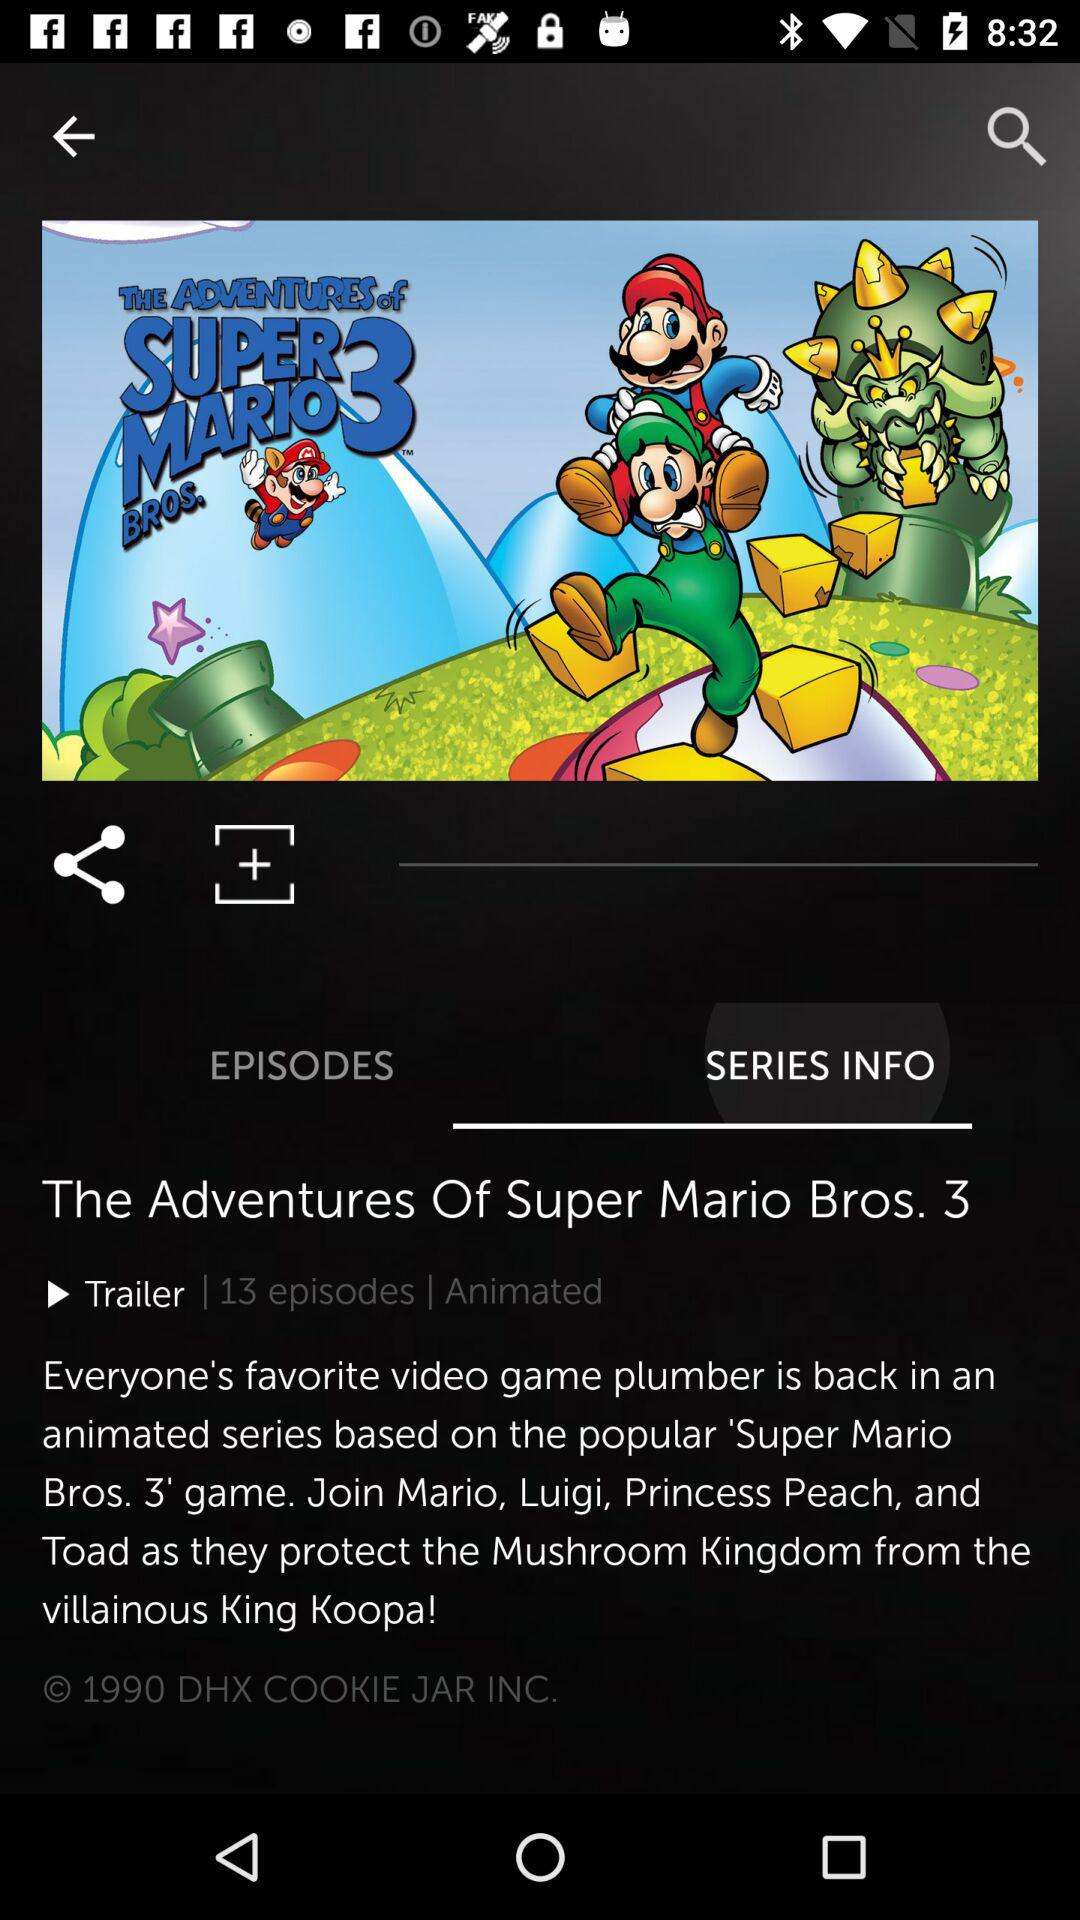What is the name of the series? The name of the series is "The Adventures Of Super Mario Bros. 3". 